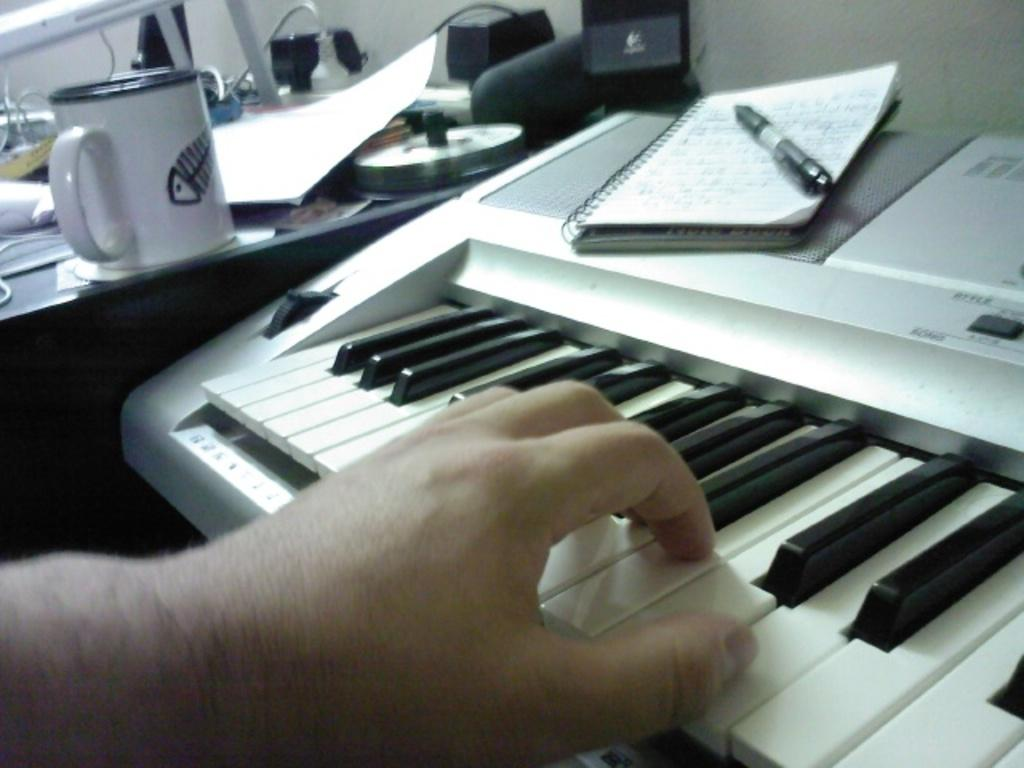What is the person's hand doing in the image? The person's hand is on a piano keyboard. What objects are on the piano keyboard? There is a book and a pen on the piano keyboard. What is on the table in the image? There is a cup and a CD on the table, as well as other unspecified things. How many ducks are visible in the image? There are no ducks present in the image. What type of laborer is working on the piano keyboard in the image? There is no laborer present in the image; it is a person's hand on the piano keyboard. 